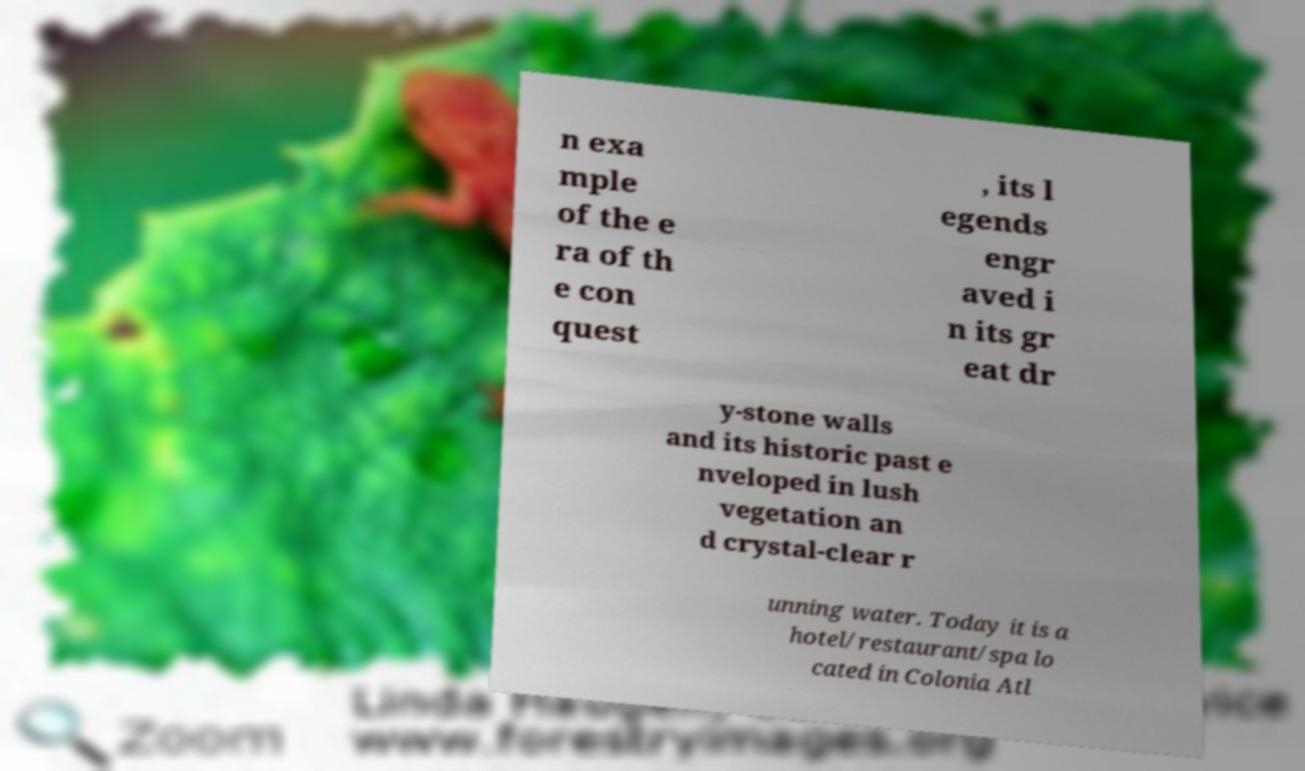Can you accurately transcribe the text from the provided image for me? n exa mple of the e ra of th e con quest , its l egends engr aved i n its gr eat dr y-stone walls and its historic past e nveloped in lush vegetation an d crystal-clear r unning water. Today it is a hotel/restaurant/spa lo cated in Colonia Atl 